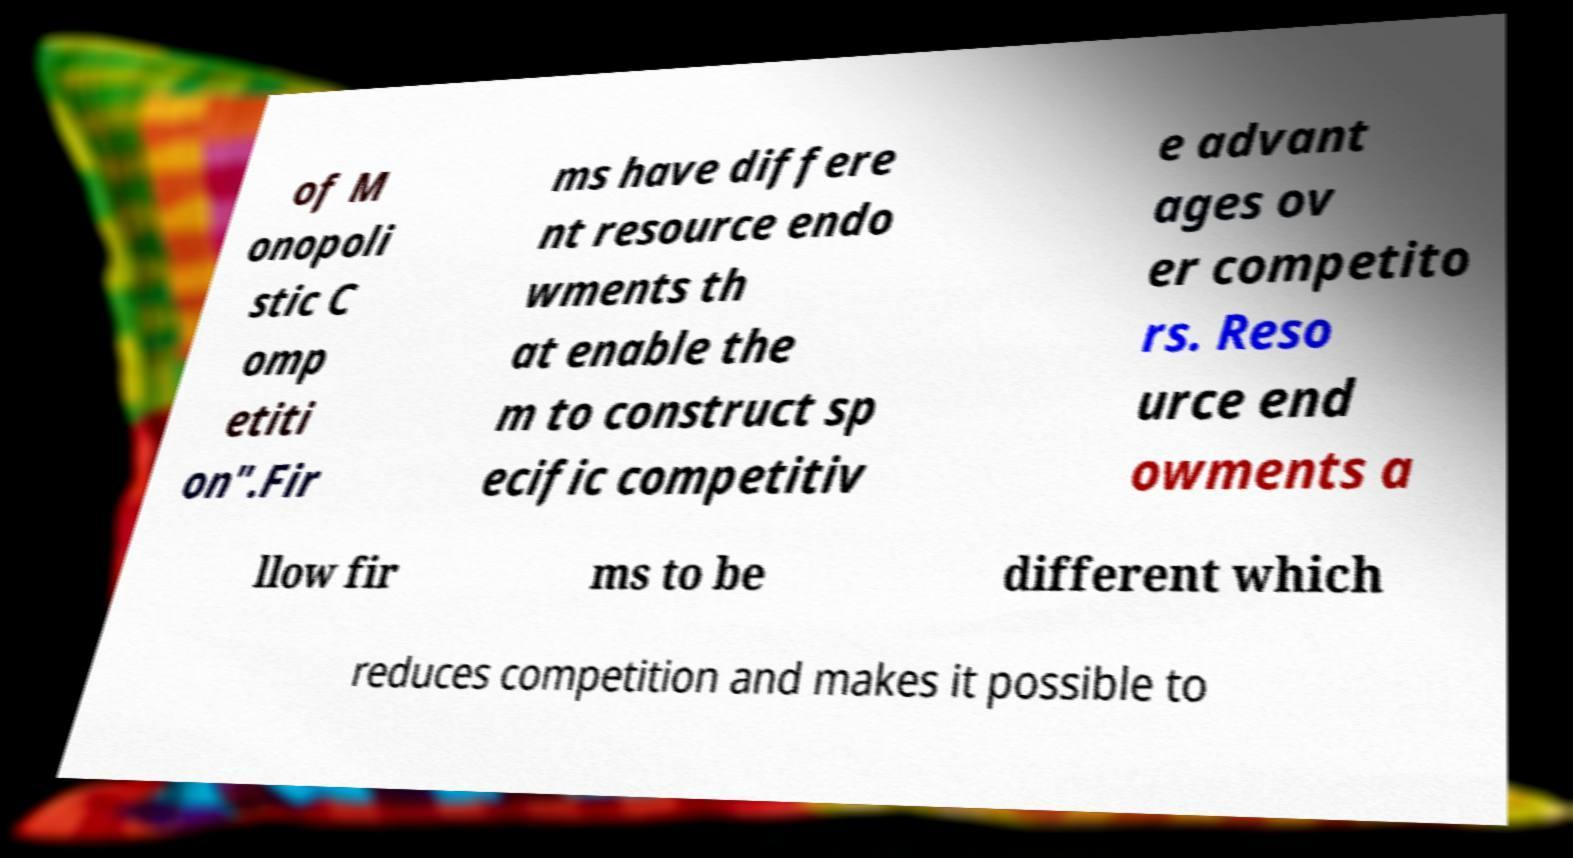There's text embedded in this image that I need extracted. Can you transcribe it verbatim? of M onopoli stic C omp etiti on".Fir ms have differe nt resource endo wments th at enable the m to construct sp ecific competitiv e advant ages ov er competito rs. Reso urce end owments a llow fir ms to be different which reduces competition and makes it possible to 